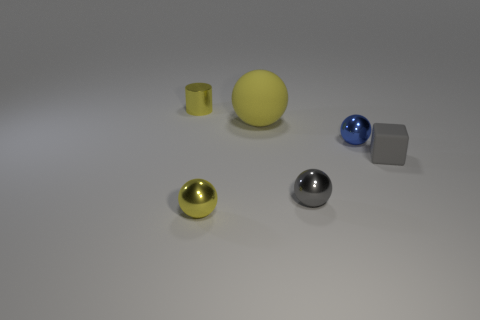How many tiny gray matte objects are there?
Provide a succinct answer. 1. There is a matte cube to the right of the small gray metallic ball that is in front of the cylinder; are there any small matte cubes behind it?
Provide a succinct answer. No. What shape is the gray metallic object that is the same size as the blue sphere?
Offer a very short reply. Sphere. What number of other things are there of the same color as the matte cube?
Keep it short and to the point. 1. What is the tiny yellow cylinder made of?
Give a very brief answer. Metal. How many other objects are the same material as the cube?
Your answer should be very brief. 1. What is the size of the sphere that is both left of the small blue object and behind the small gray cube?
Your answer should be very brief. Large. What shape is the small yellow metal object in front of the matte thing on the left side of the tiny gray sphere?
Your response must be concise. Sphere. Are there any other things that have the same shape as the large yellow rubber object?
Your answer should be compact. Yes. Are there an equal number of metal objects that are right of the big sphere and rubber things?
Ensure brevity in your answer.  Yes. 